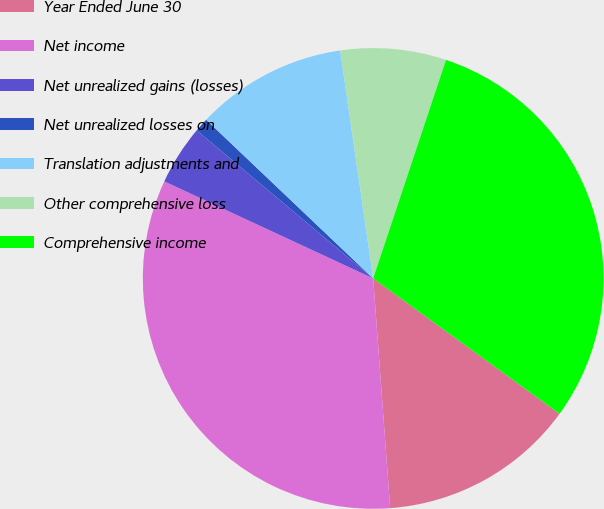<chart> <loc_0><loc_0><loc_500><loc_500><pie_chart><fcel>Year Ended June 30<fcel>Net income<fcel>Net unrealized gains (losses)<fcel>Net unrealized losses on<fcel>Translation adjustments and<fcel>Other comprehensive loss<fcel>Comprehensive income<nl><fcel>13.83%<fcel>33.1%<fcel>4.19%<fcel>0.98%<fcel>10.62%<fcel>7.41%<fcel>29.88%<nl></chart> 